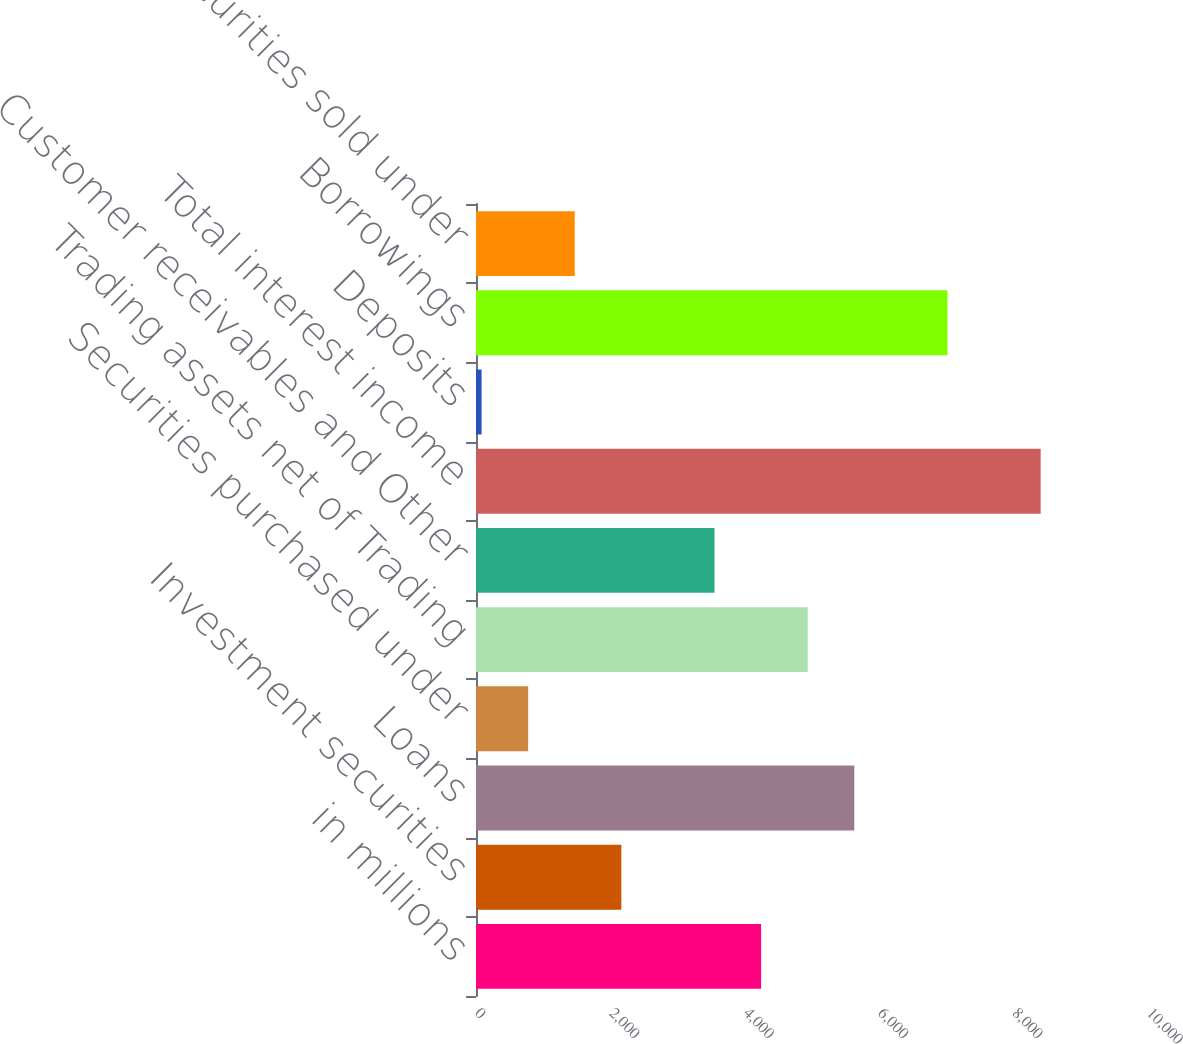Convert chart to OTSL. <chart><loc_0><loc_0><loc_500><loc_500><bar_chart><fcel>in millions<fcel>Investment securities<fcel>Loans<fcel>Securities purchased under<fcel>Trading assets net of Trading<fcel>Customer receivables and Other<fcel>Total interest income<fcel>Deposits<fcel>Borrowings<fcel>Securities sold under<nl><fcel>4242.8<fcel>2162.9<fcel>5629.4<fcel>776.3<fcel>4936.1<fcel>3549.5<fcel>8402.6<fcel>83<fcel>7016<fcel>1469.6<nl></chart> 